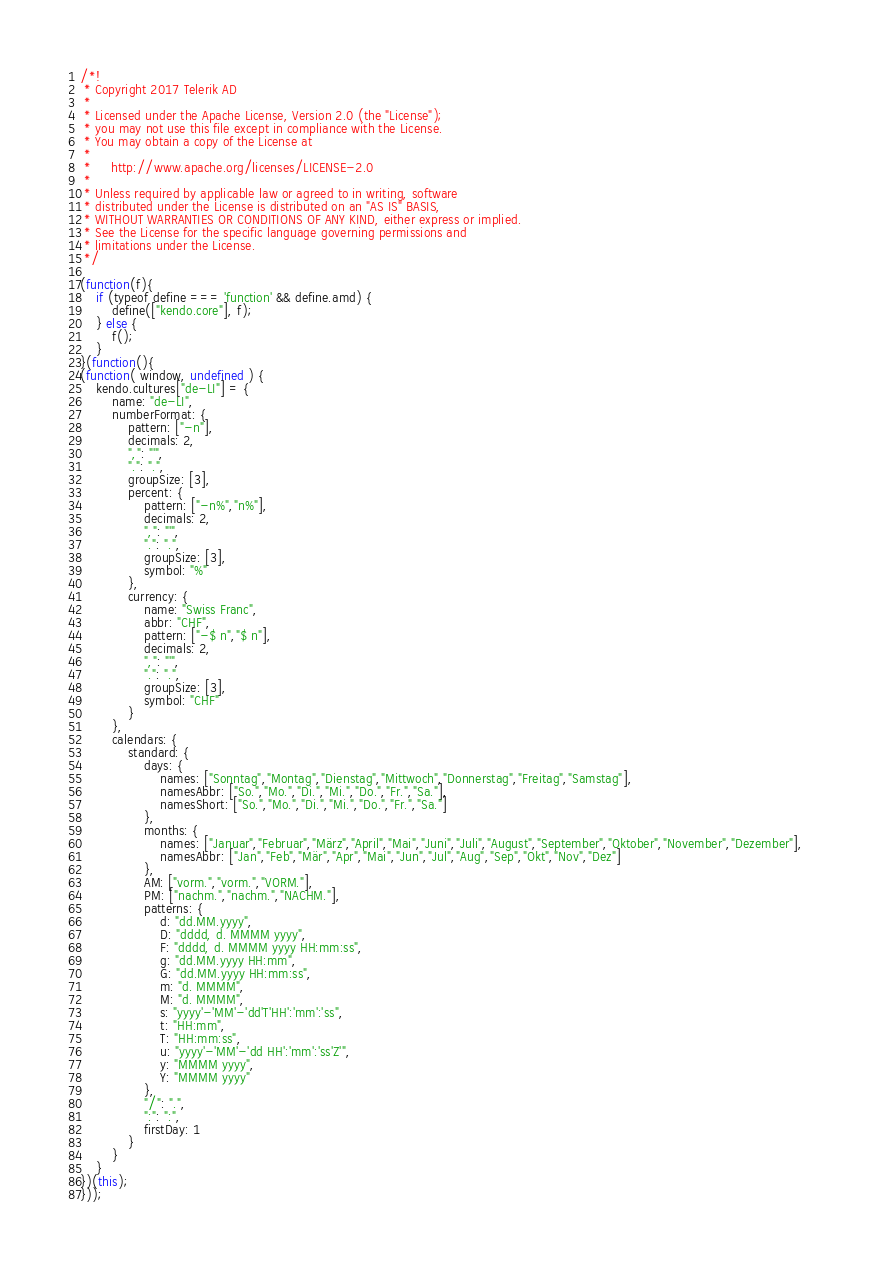<code> <loc_0><loc_0><loc_500><loc_500><_JavaScript_>/*!
 * Copyright 2017 Telerik AD
 *
 * Licensed under the Apache License, Version 2.0 (the "License");
 * you may not use this file except in compliance with the License.
 * You may obtain a copy of the License at
 *
 *     http://www.apache.org/licenses/LICENSE-2.0
 *
 * Unless required by applicable law or agreed to in writing, software
 * distributed under the License is distributed on an "AS IS" BASIS,
 * WITHOUT WARRANTIES OR CONDITIONS OF ANY KIND, either express or implied.
 * See the License for the specific language governing permissions and
 * limitations under the License.
 */

(function(f){
    if (typeof define === 'function' && define.amd) {
        define(["kendo.core"], f);
    } else {
        f();
    }
}(function(){
(function( window, undefined ) {
    kendo.cultures["de-LI"] = {
        name: "de-LI",
        numberFormat: {
            pattern: ["-n"],
            decimals: 2,
            ",": "'",
            ".": ".",
            groupSize: [3],
            percent: {
                pattern: ["-n%","n%"],
                decimals: 2,
                ",": "'",
                ".": ".",
                groupSize: [3],
                symbol: "%"
            },
            currency: {
                name: "Swiss Franc",
                abbr: "CHF",
                pattern: ["-$ n","$ n"],
                decimals: 2,
                ",": "'",
                ".": ".",
                groupSize: [3],
                symbol: "CHF"
            }
        },
        calendars: {
            standard: {
                days: {
                    names: ["Sonntag","Montag","Dienstag","Mittwoch","Donnerstag","Freitag","Samstag"],
                    namesAbbr: ["So.","Mo.","Di.","Mi.","Do.","Fr.","Sa."],
                    namesShort: ["So.","Mo.","Di.","Mi.","Do.","Fr.","Sa."]
                },
                months: {
                    names: ["Januar","Februar","März","April","Mai","Juni","Juli","August","September","Oktober","November","Dezember"],
                    namesAbbr: ["Jan","Feb","Mär","Apr","Mai","Jun","Jul","Aug","Sep","Okt","Nov","Dez"]
                },
                AM: ["vorm.","vorm.","VORM."],
                PM: ["nachm.","nachm.","NACHM."],
                patterns: {
                    d: "dd.MM.yyyy",
                    D: "dddd, d. MMMM yyyy",
                    F: "dddd, d. MMMM yyyy HH:mm:ss",
                    g: "dd.MM.yyyy HH:mm",
                    G: "dd.MM.yyyy HH:mm:ss",
                    m: "d. MMMM",
                    M: "d. MMMM",
                    s: "yyyy'-'MM'-'dd'T'HH':'mm':'ss",
                    t: "HH:mm",
                    T: "HH:mm:ss",
                    u: "yyyy'-'MM'-'dd HH':'mm':'ss'Z'",
                    y: "MMMM yyyy",
                    Y: "MMMM yyyy"
                },
                "/": ".",
                ":": ":",
                firstDay: 1
            }
        }
    }
})(this);
}));</code> 